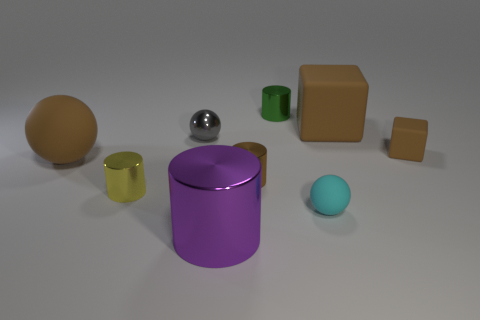Subtract all tiny green metallic cylinders. How many cylinders are left? 3 Add 1 green shiny cylinders. How many objects exist? 10 Subtract 2 spheres. How many spheres are left? 1 Subtract all gray spheres. How many spheres are left? 2 Subtract all spheres. How many objects are left? 6 Subtract all green cylinders. Subtract all purple cubes. How many cylinders are left? 3 Subtract all tiny metallic cylinders. Subtract all large balls. How many objects are left? 5 Add 6 brown things. How many brown things are left? 10 Add 4 big yellow cylinders. How many big yellow cylinders exist? 4 Subtract 1 brown balls. How many objects are left? 8 